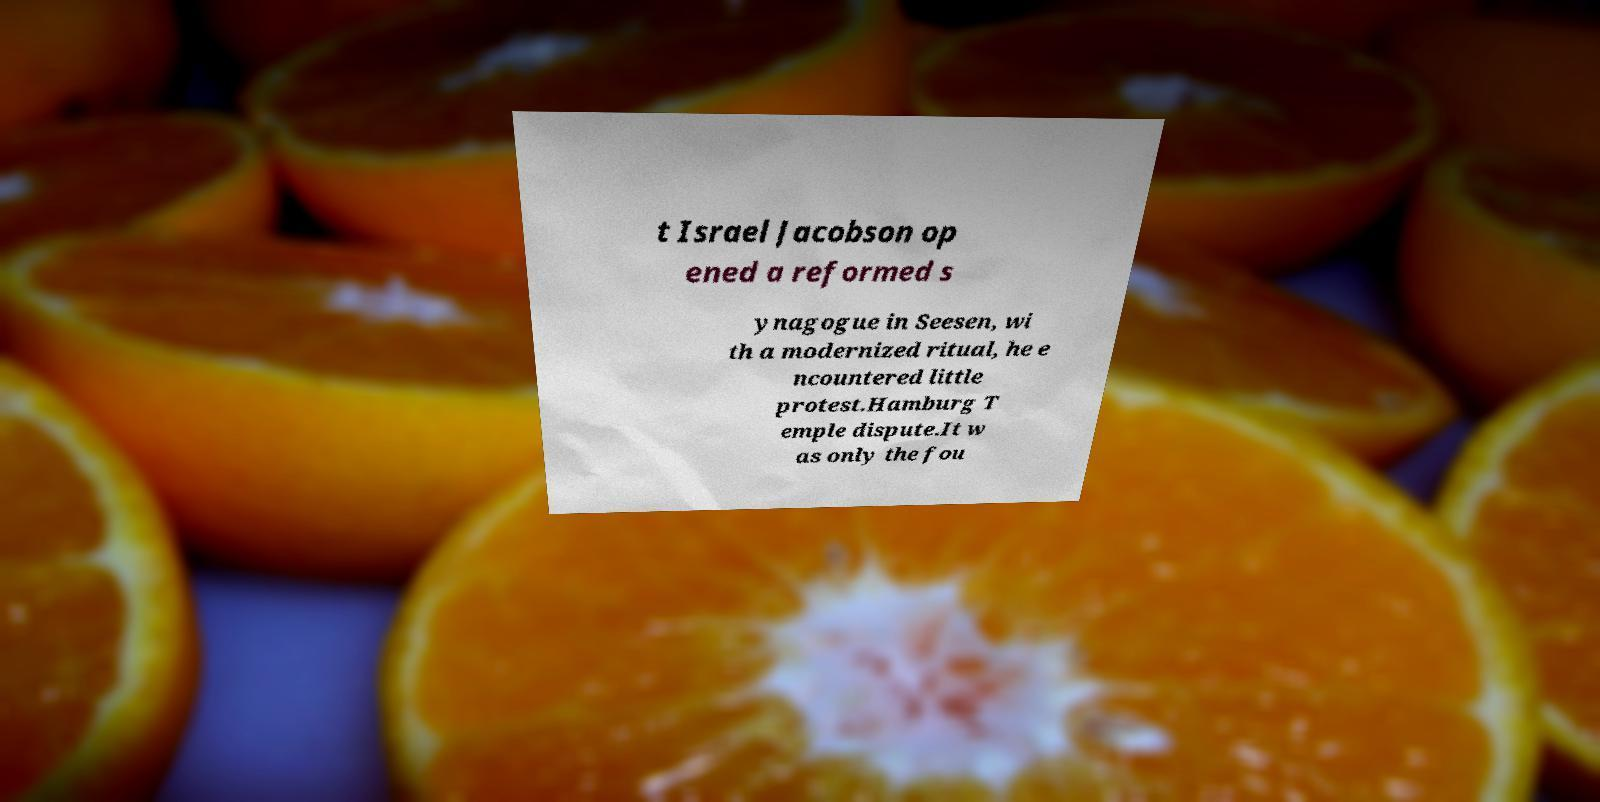I need the written content from this picture converted into text. Can you do that? t Israel Jacobson op ened a reformed s ynagogue in Seesen, wi th a modernized ritual, he e ncountered little protest.Hamburg T emple dispute.It w as only the fou 